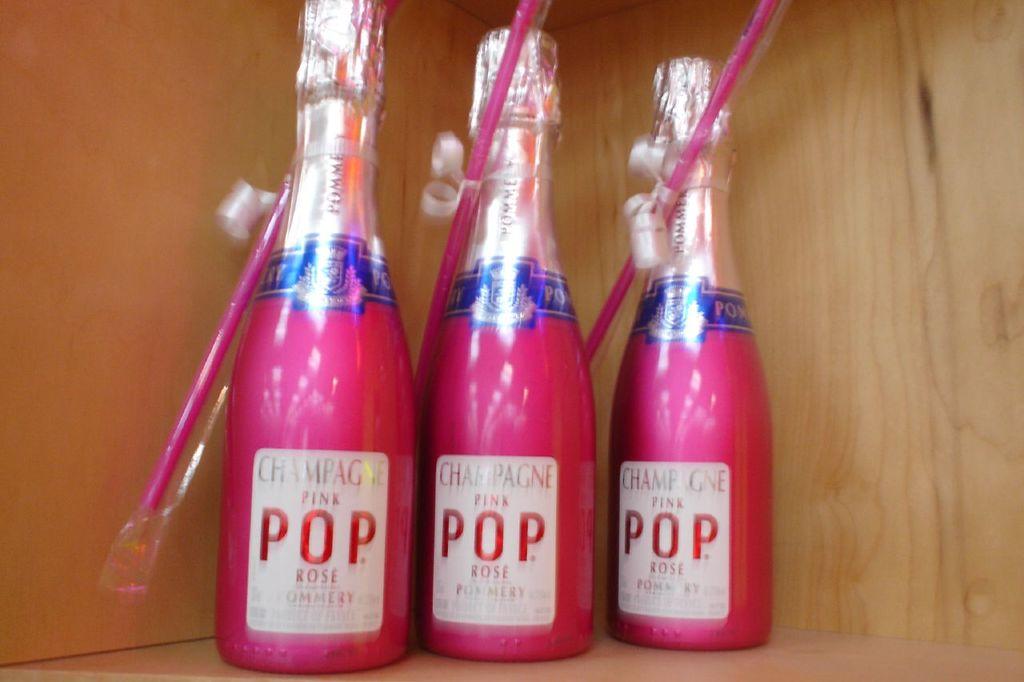The drink is called pink what?
Provide a succinct answer. Pop. What type of beverage is this?
Your answer should be very brief. Champagne. 